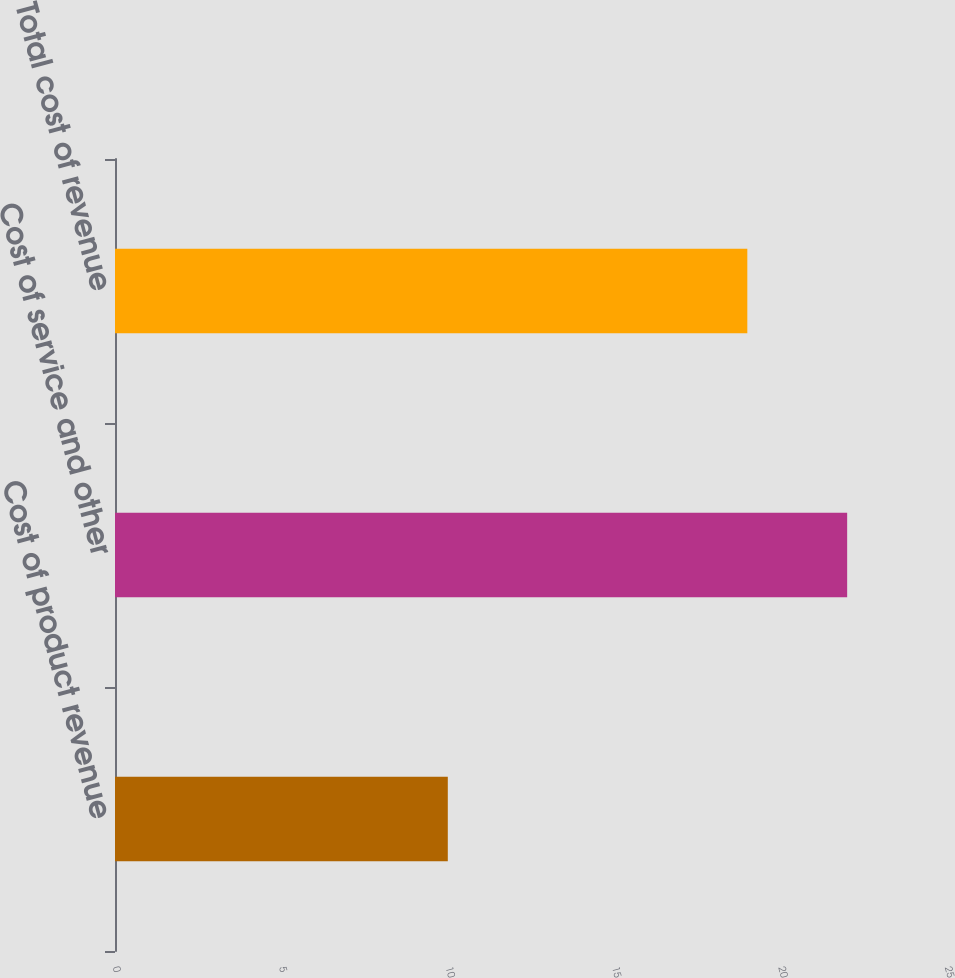<chart> <loc_0><loc_0><loc_500><loc_500><bar_chart><fcel>Cost of product revenue<fcel>Cost of service and other<fcel>Total cost of revenue<nl><fcel>10<fcel>22<fcel>19<nl></chart> 